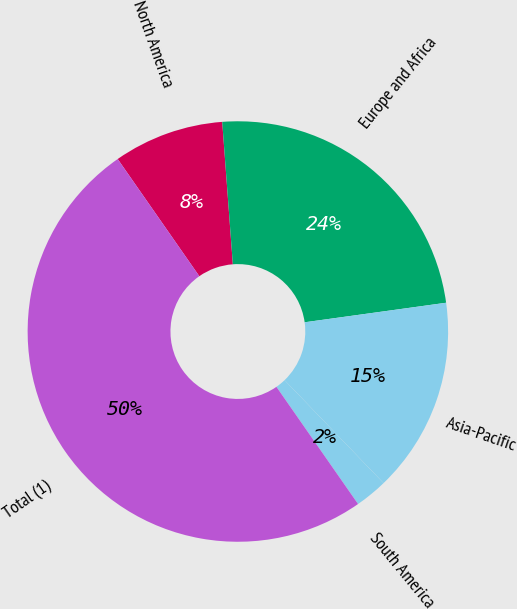Convert chart. <chart><loc_0><loc_0><loc_500><loc_500><pie_chart><fcel>North America<fcel>Europe and Africa<fcel>Asia-Pacific<fcel>South America<fcel>Total (1)<nl><fcel>8.5%<fcel>24.0%<fcel>15.0%<fcel>2.5%<fcel>50.0%<nl></chart> 